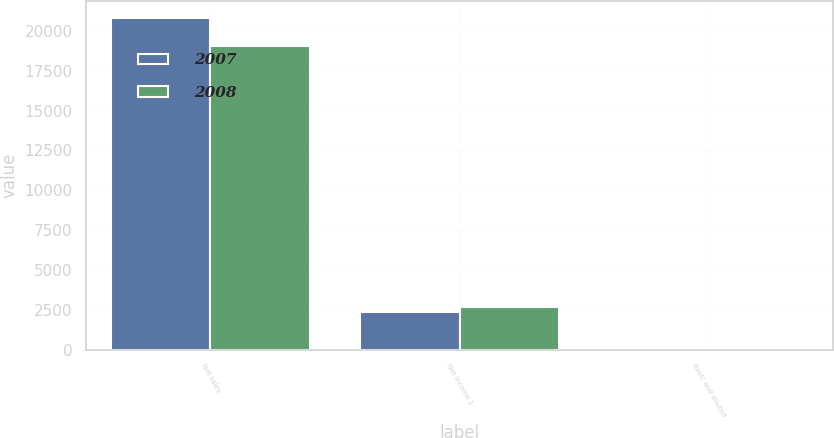Convert chart. <chart><loc_0><loc_0><loc_500><loc_500><stacked_bar_chart><ecel><fcel>Net sales<fcel>Net income 1<fcel>Basic and diluted<nl><fcel>2007<fcel>20801.8<fcel>2356.2<fcel>2.15<nl><fcel>2008<fcel>19051.4<fcel>2704.1<fcel>2.48<nl></chart> 